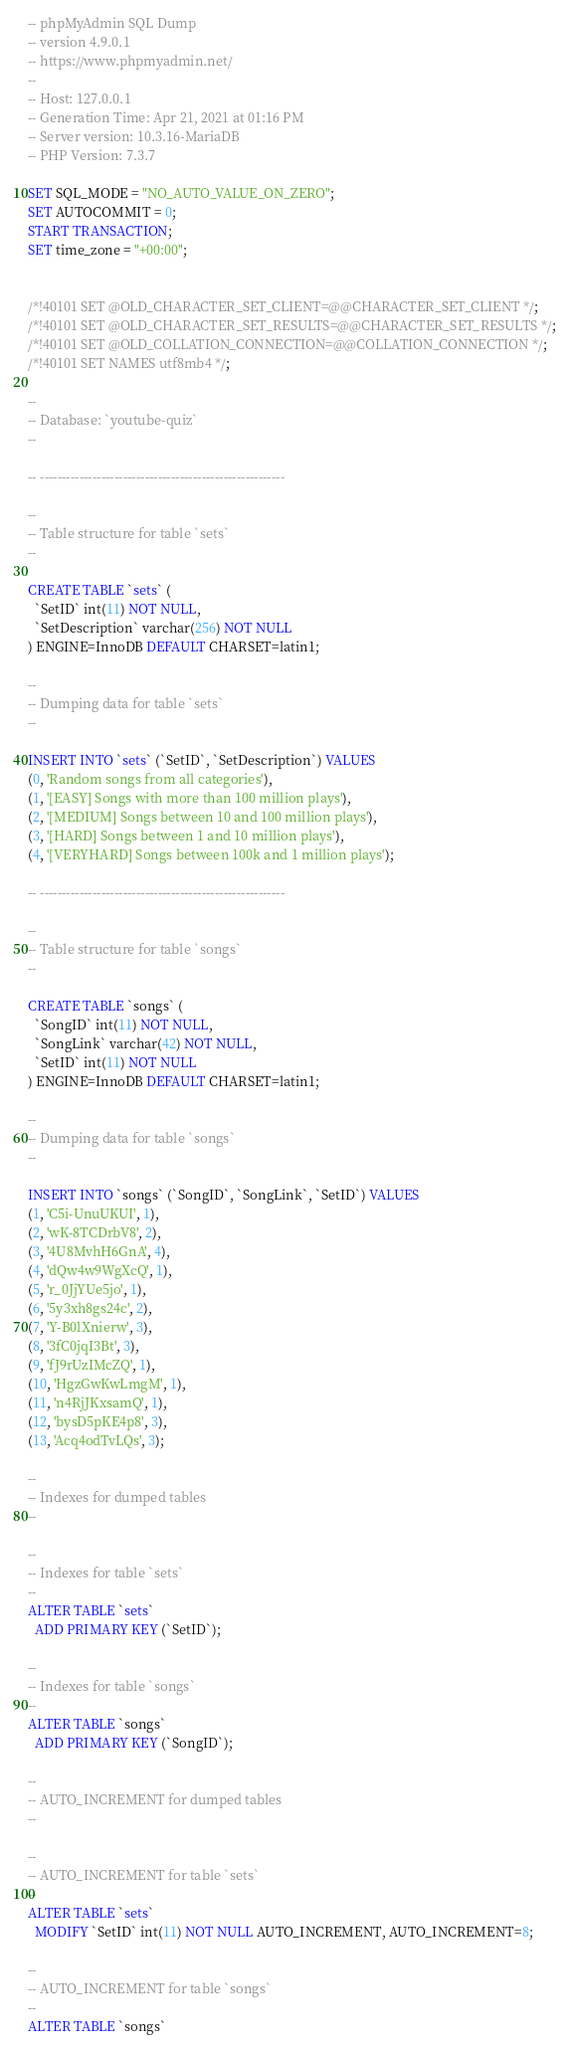<code> <loc_0><loc_0><loc_500><loc_500><_SQL_>-- phpMyAdmin SQL Dump
-- version 4.9.0.1
-- https://www.phpmyadmin.net/
--
-- Host: 127.0.0.1
-- Generation Time: Apr 21, 2021 at 01:16 PM
-- Server version: 10.3.16-MariaDB
-- PHP Version: 7.3.7

SET SQL_MODE = "NO_AUTO_VALUE_ON_ZERO";
SET AUTOCOMMIT = 0;
START TRANSACTION;
SET time_zone = "+00:00";


/*!40101 SET @OLD_CHARACTER_SET_CLIENT=@@CHARACTER_SET_CLIENT */;
/*!40101 SET @OLD_CHARACTER_SET_RESULTS=@@CHARACTER_SET_RESULTS */;
/*!40101 SET @OLD_COLLATION_CONNECTION=@@COLLATION_CONNECTION */;
/*!40101 SET NAMES utf8mb4 */;

--
-- Database: `youtube-quiz`
--

-- --------------------------------------------------------

--
-- Table structure for table `sets`
--

CREATE TABLE `sets` (
  `SetID` int(11) NOT NULL,
  `SetDescription` varchar(256) NOT NULL
) ENGINE=InnoDB DEFAULT CHARSET=latin1;

--
-- Dumping data for table `sets`
--

INSERT INTO `sets` (`SetID`, `SetDescription`) VALUES
(0, 'Random songs from all categories'),
(1, '[EASY] Songs with more than 100 million plays'),
(2, '[MEDIUM] Songs between 10 and 100 million plays'),
(3, '[HARD] Songs between 1 and 10 million plays'),
(4, '[VERYHARD] Songs between 100k and 1 million plays');

-- --------------------------------------------------------

--
-- Table structure for table `songs`
--

CREATE TABLE `songs` (
  `SongID` int(11) NOT NULL,
  `SongLink` varchar(42) NOT NULL,
  `SetID` int(11) NOT NULL
) ENGINE=InnoDB DEFAULT CHARSET=latin1;

--
-- Dumping data for table `songs`
--

INSERT INTO `songs` (`SongID`, `SongLink`, `SetID`) VALUES
(1, 'C5i-UnuUKUI', 1),
(2, 'wK-8TCDrbV8', 2),
(3, '4U8MvhH6GnA', 4),
(4, 'dQw4w9WgXcQ', 1),
(5, 'r_0JjYUe5jo', 1),
(6, '5y3xh8gs24c', 2),
(7, 'Y-B0lXnierw', 3),
(8, '3fC0jqI3Bt', 3),
(9, 'fJ9rUzIMcZQ', 1),
(10, 'HgzGwKwLmgM', 1),
(11, 'n4RjJKxsamQ', 1),
(12, 'bysD5pKE4p8', 3),
(13, 'Acq4odTvLQs', 3);

--
-- Indexes for dumped tables
--

--
-- Indexes for table `sets`
--
ALTER TABLE `sets`
  ADD PRIMARY KEY (`SetID`);

--
-- Indexes for table `songs`
--
ALTER TABLE `songs`
  ADD PRIMARY KEY (`SongID`);

--
-- AUTO_INCREMENT for dumped tables
--

--
-- AUTO_INCREMENT for table `sets`
--
ALTER TABLE `sets`
  MODIFY `SetID` int(11) NOT NULL AUTO_INCREMENT, AUTO_INCREMENT=8;

--
-- AUTO_INCREMENT for table `songs`
--
ALTER TABLE `songs`</code> 